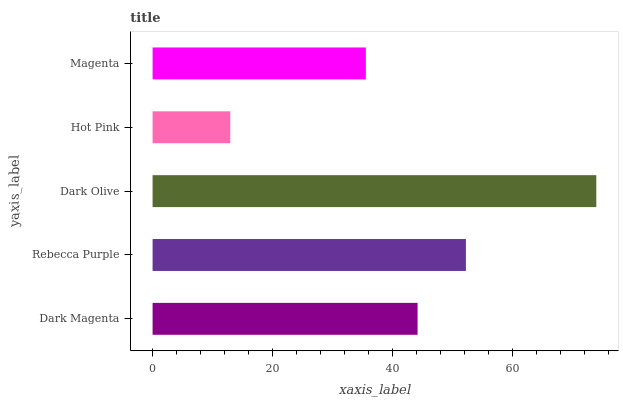Is Hot Pink the minimum?
Answer yes or no. Yes. Is Dark Olive the maximum?
Answer yes or no. Yes. Is Rebecca Purple the minimum?
Answer yes or no. No. Is Rebecca Purple the maximum?
Answer yes or no. No. Is Rebecca Purple greater than Dark Magenta?
Answer yes or no. Yes. Is Dark Magenta less than Rebecca Purple?
Answer yes or no. Yes. Is Dark Magenta greater than Rebecca Purple?
Answer yes or no. No. Is Rebecca Purple less than Dark Magenta?
Answer yes or no. No. Is Dark Magenta the high median?
Answer yes or no. Yes. Is Dark Magenta the low median?
Answer yes or no. Yes. Is Dark Olive the high median?
Answer yes or no. No. Is Magenta the low median?
Answer yes or no. No. 